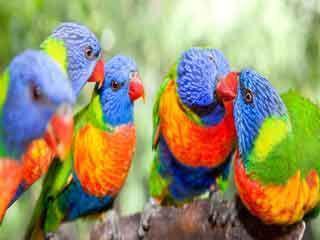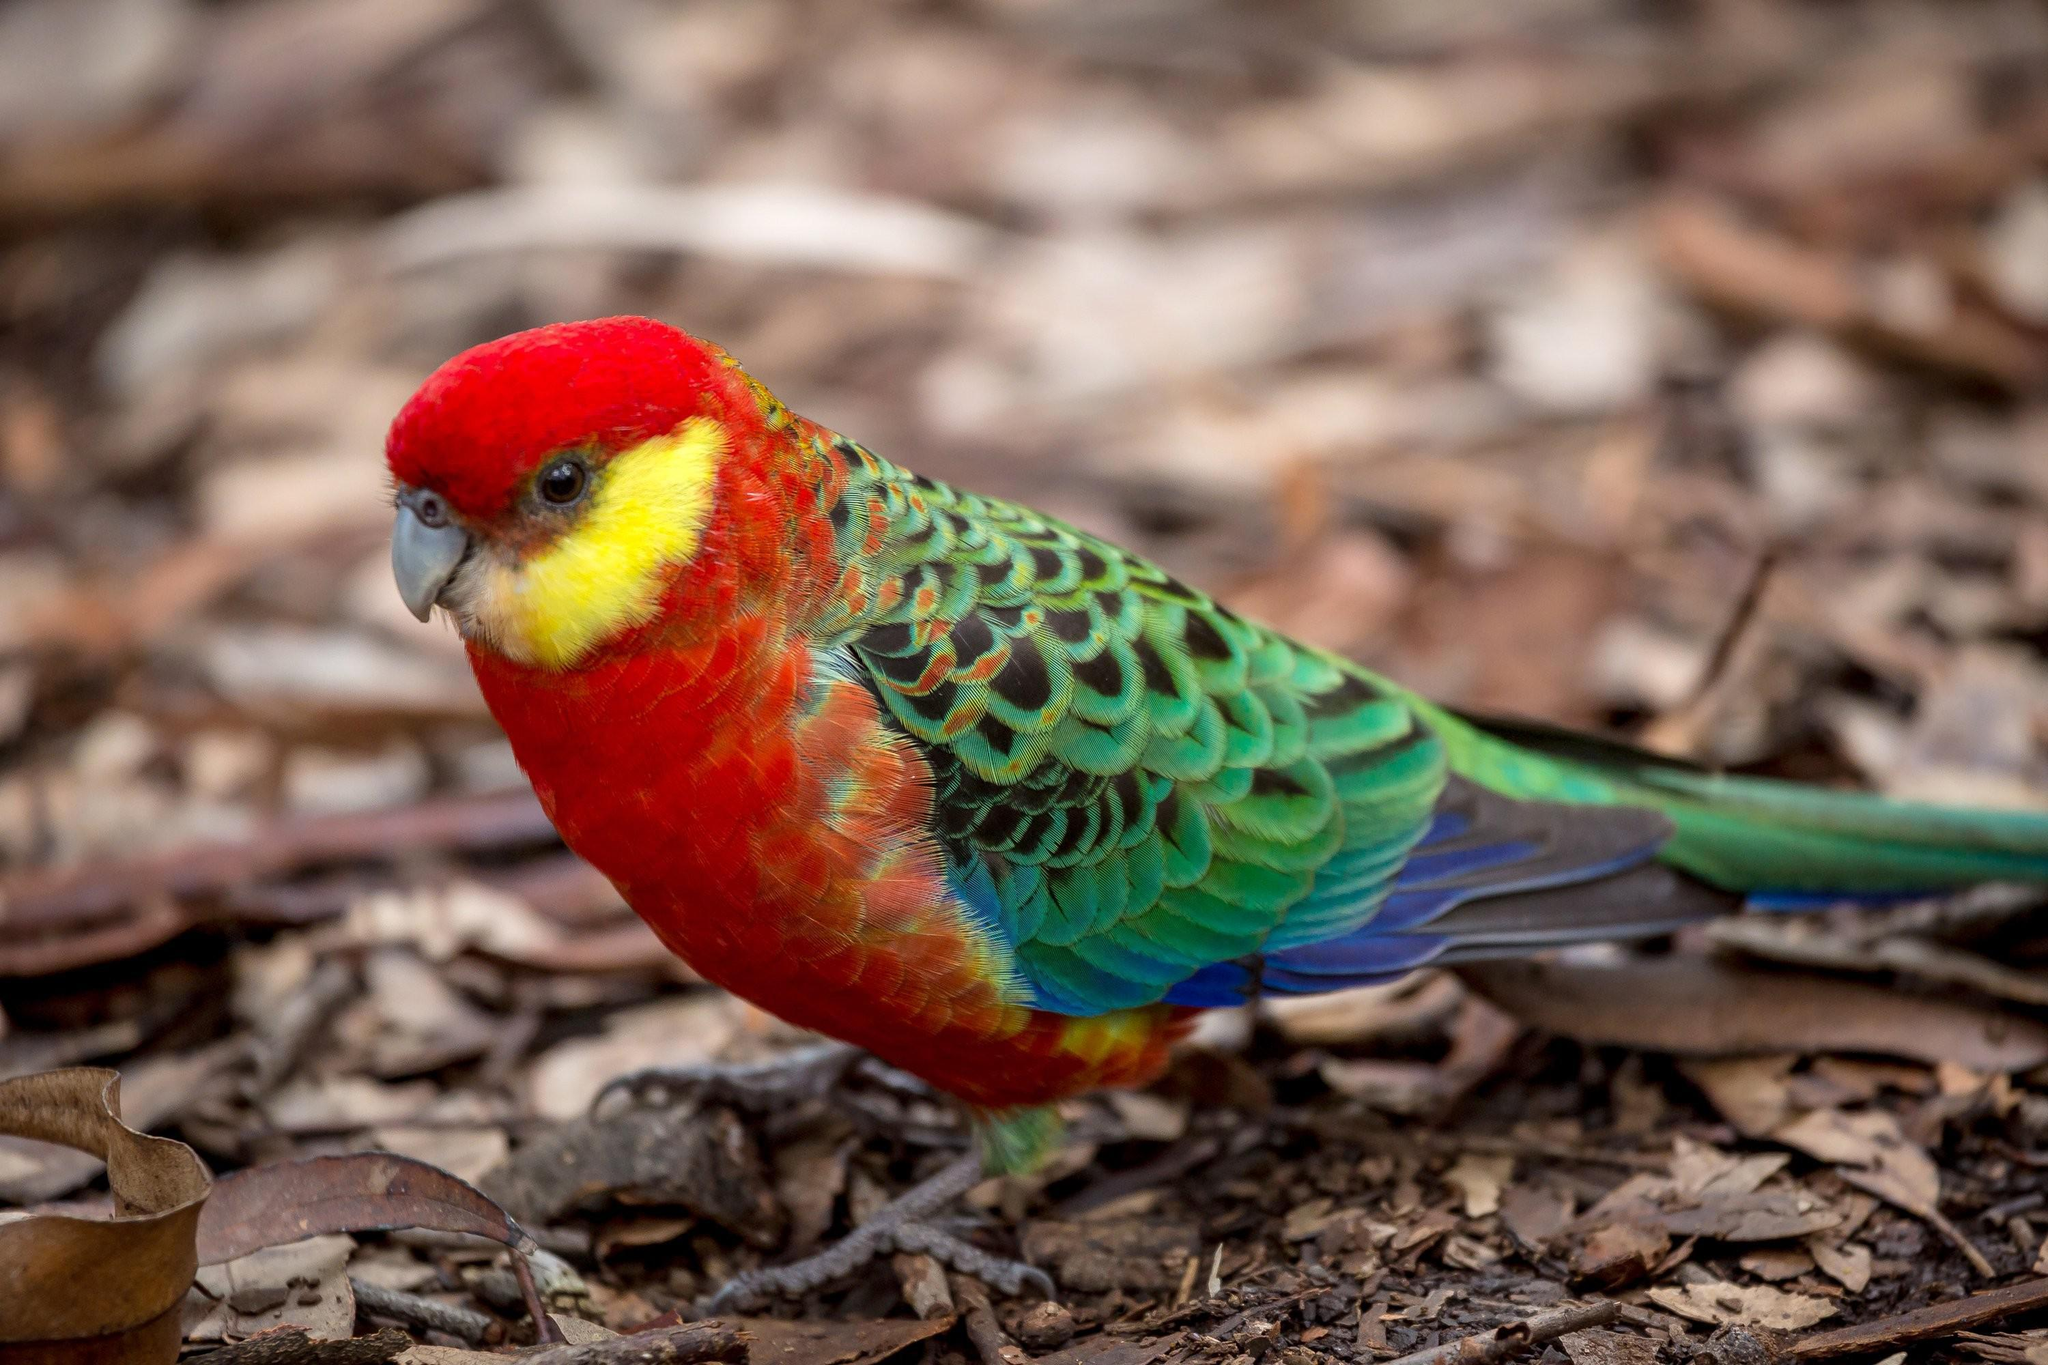The first image is the image on the left, the second image is the image on the right. Given the left and right images, does the statement "An image features a horizontal row of at least four perched blue-headed parrots." hold true? Answer yes or no. Yes. The first image is the image on the left, the second image is the image on the right. Given the left and right images, does the statement "There's no more than one parrot in the right image." hold true? Answer yes or no. Yes. 